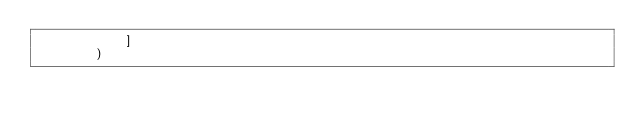Convert code to text. <code><loc_0><loc_0><loc_500><loc_500><_Python_>            ]
        )
</code> 